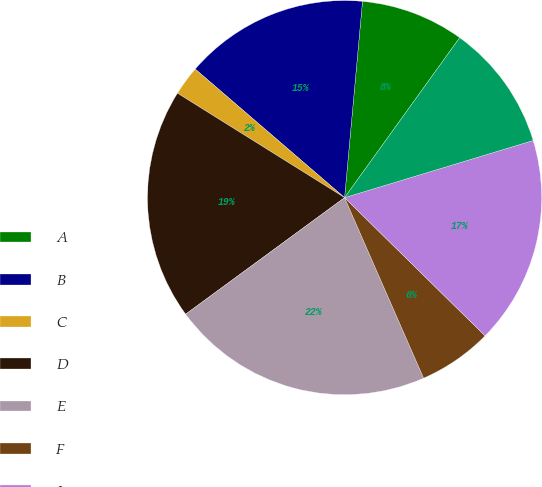Convert chart. <chart><loc_0><loc_0><loc_500><loc_500><pie_chart><fcel>A<fcel>B<fcel>C<fcel>D<fcel>E<fcel>F<fcel>I<fcel>J<nl><fcel>8.48%<fcel>15.14%<fcel>2.42%<fcel>18.96%<fcel>21.5%<fcel>6.06%<fcel>17.05%<fcel>10.39%<nl></chart> 